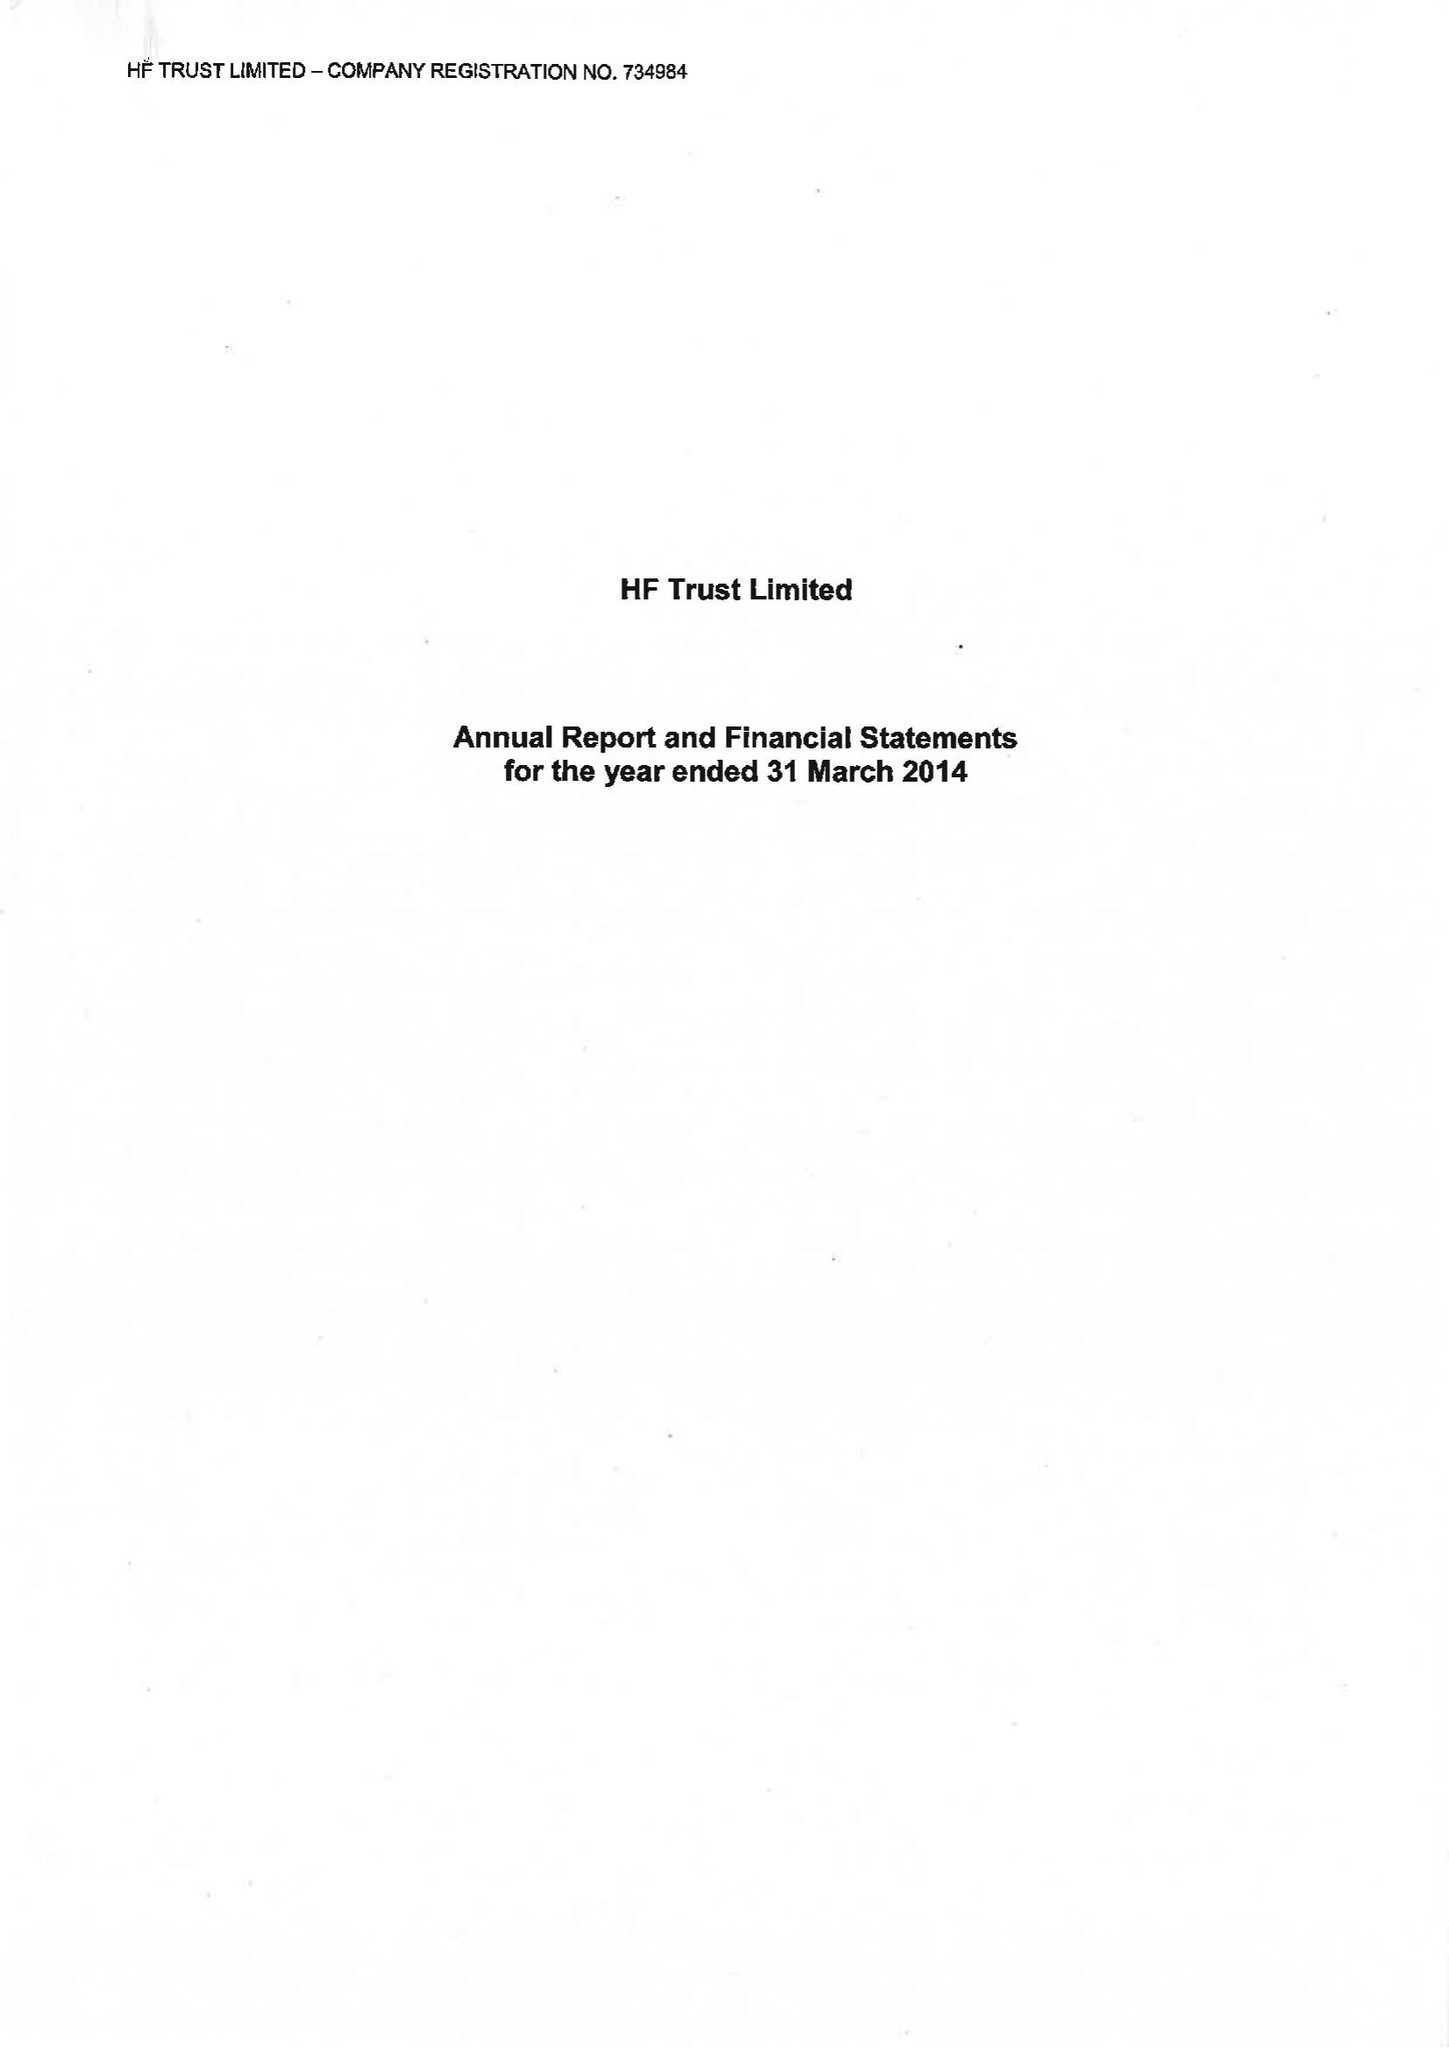What is the value for the income_annually_in_british_pounds?
Answer the question using a single word or phrase. 98817000.00 